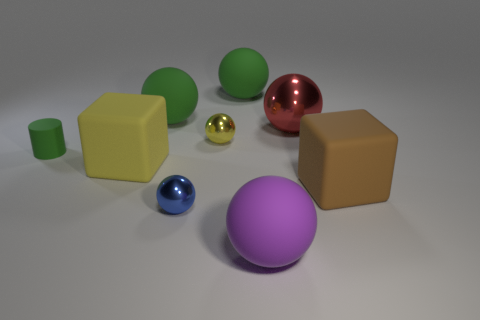Subtract all purple spheres. How many spheres are left? 5 Subtract all small yellow spheres. How many spheres are left? 5 Subtract all cyan balls. Subtract all brown cubes. How many balls are left? 6 Add 1 green rubber things. How many objects exist? 10 Subtract all spheres. How many objects are left? 3 Subtract all tiny yellow blocks. Subtract all big metallic spheres. How many objects are left? 8 Add 5 tiny yellow metallic balls. How many tiny yellow metallic balls are left? 6 Add 2 metallic things. How many metallic things exist? 5 Subtract 1 green cylinders. How many objects are left? 8 